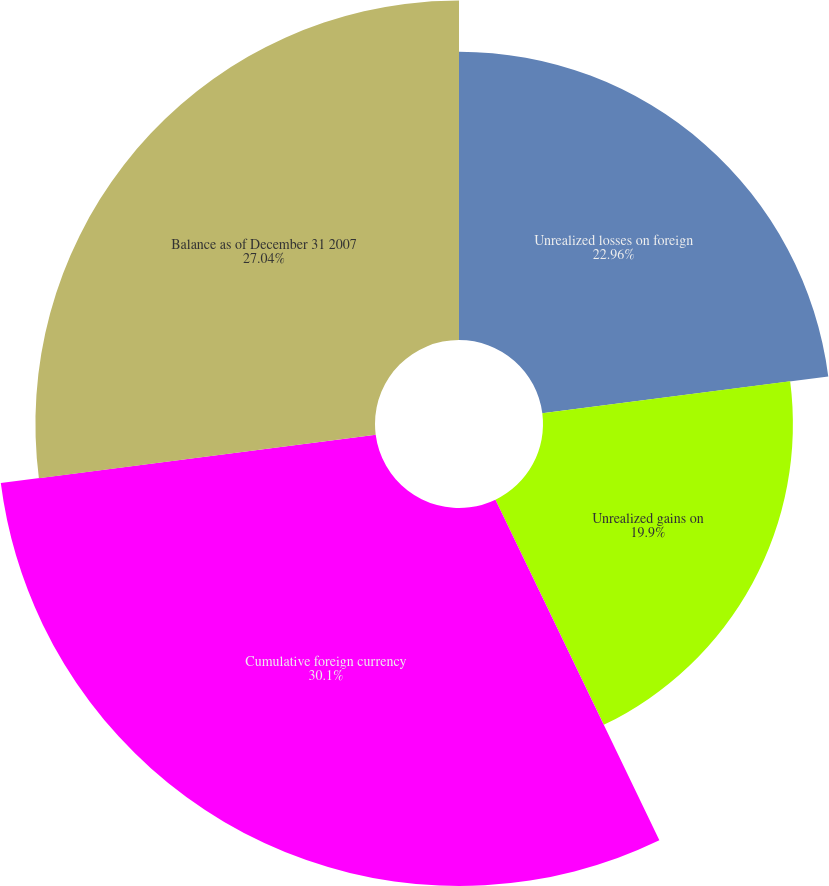Convert chart to OTSL. <chart><loc_0><loc_0><loc_500><loc_500><pie_chart><fcel>Unrealized losses on foreign<fcel>Unrealized gains on<fcel>Cumulative foreign currency<fcel>Balance as of December 31 2007<nl><fcel>22.96%<fcel>19.9%<fcel>30.1%<fcel>27.04%<nl></chart> 